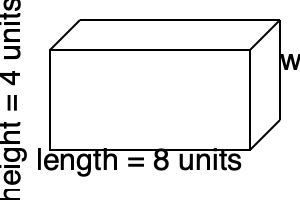Given a rectangular prism with dimensions length = 8 units, width = 3 units, and height = 4 units, calculate its volume. How would you explain this calculation to a student learning about 3D space optimization in computer systems? To calculate the volume of a rectangular prism and explain it in the context of computer systems, we can follow these steps:

1. Understand the formula:
   The volume of a rectangular prism is given by the formula:
   $$ V = l \times w \times h $$
   Where $V$ is volume, $l$ is length, $w$ is width, and $h$ is height.

2. Relate to computer systems:
   In computer science, we often deal with 3D space optimization, such as in data centers or memory allocation. The volume calculation can be likened to determining the total storage capacity of a server rack or the memory space required for a 3D array.

3. Apply the formula:
   Given the dimensions:
   $l = 8$ units
   $w = 3$ units
   $h = 4$ units

   We can substitute these values into our formula:
   $$ V = 8 \times 3 \times 4 $$

4. Perform the calculation:
   $$ V = 24 \times 4 = 96 $$

5. Interpret the result:
   The volume is 96 cubic units. In a computer system context, this could represent 96 units of storage space or memory allocation.

6. Efficiency consideration:
   Just as we aim for efficient use of physical space in a data center, we also strive for efficient use of memory in programming. Understanding volume calculations helps in optimizing resource allocation and utilization in computer systems.
Answer: 96 cubic units 